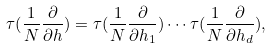Convert formula to latex. <formula><loc_0><loc_0><loc_500><loc_500>\tau ( \frac { 1 } { N } \frac { \partial } { \partial h } ) = \tau ( \frac { 1 } { N } \frac { \partial } { \partial h _ { 1 } } ) \cdots \tau ( \frac { 1 } { N } \frac { \partial } { \partial h _ { d } } ) ,</formula> 